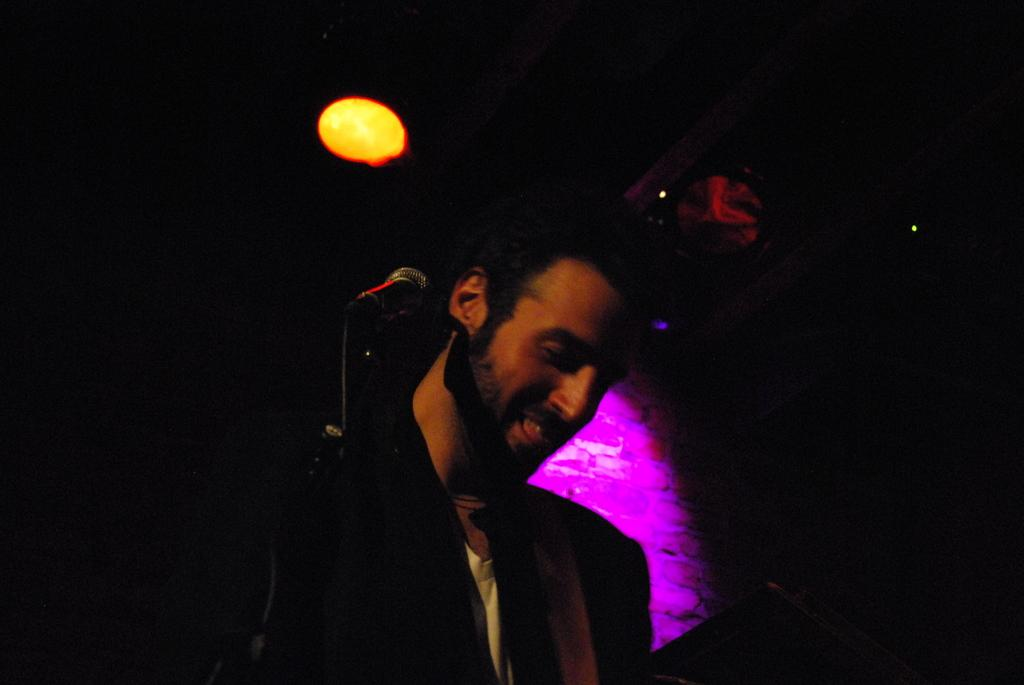What is the main subject of the image? There is a man standing in the center of the image. What object can be seen near the man? There is a mic stand in the image. What type of notebook is the man using during the meeting in the image? There is no meeting or notebook present in the image; it only features a man standing near a mic stand. 